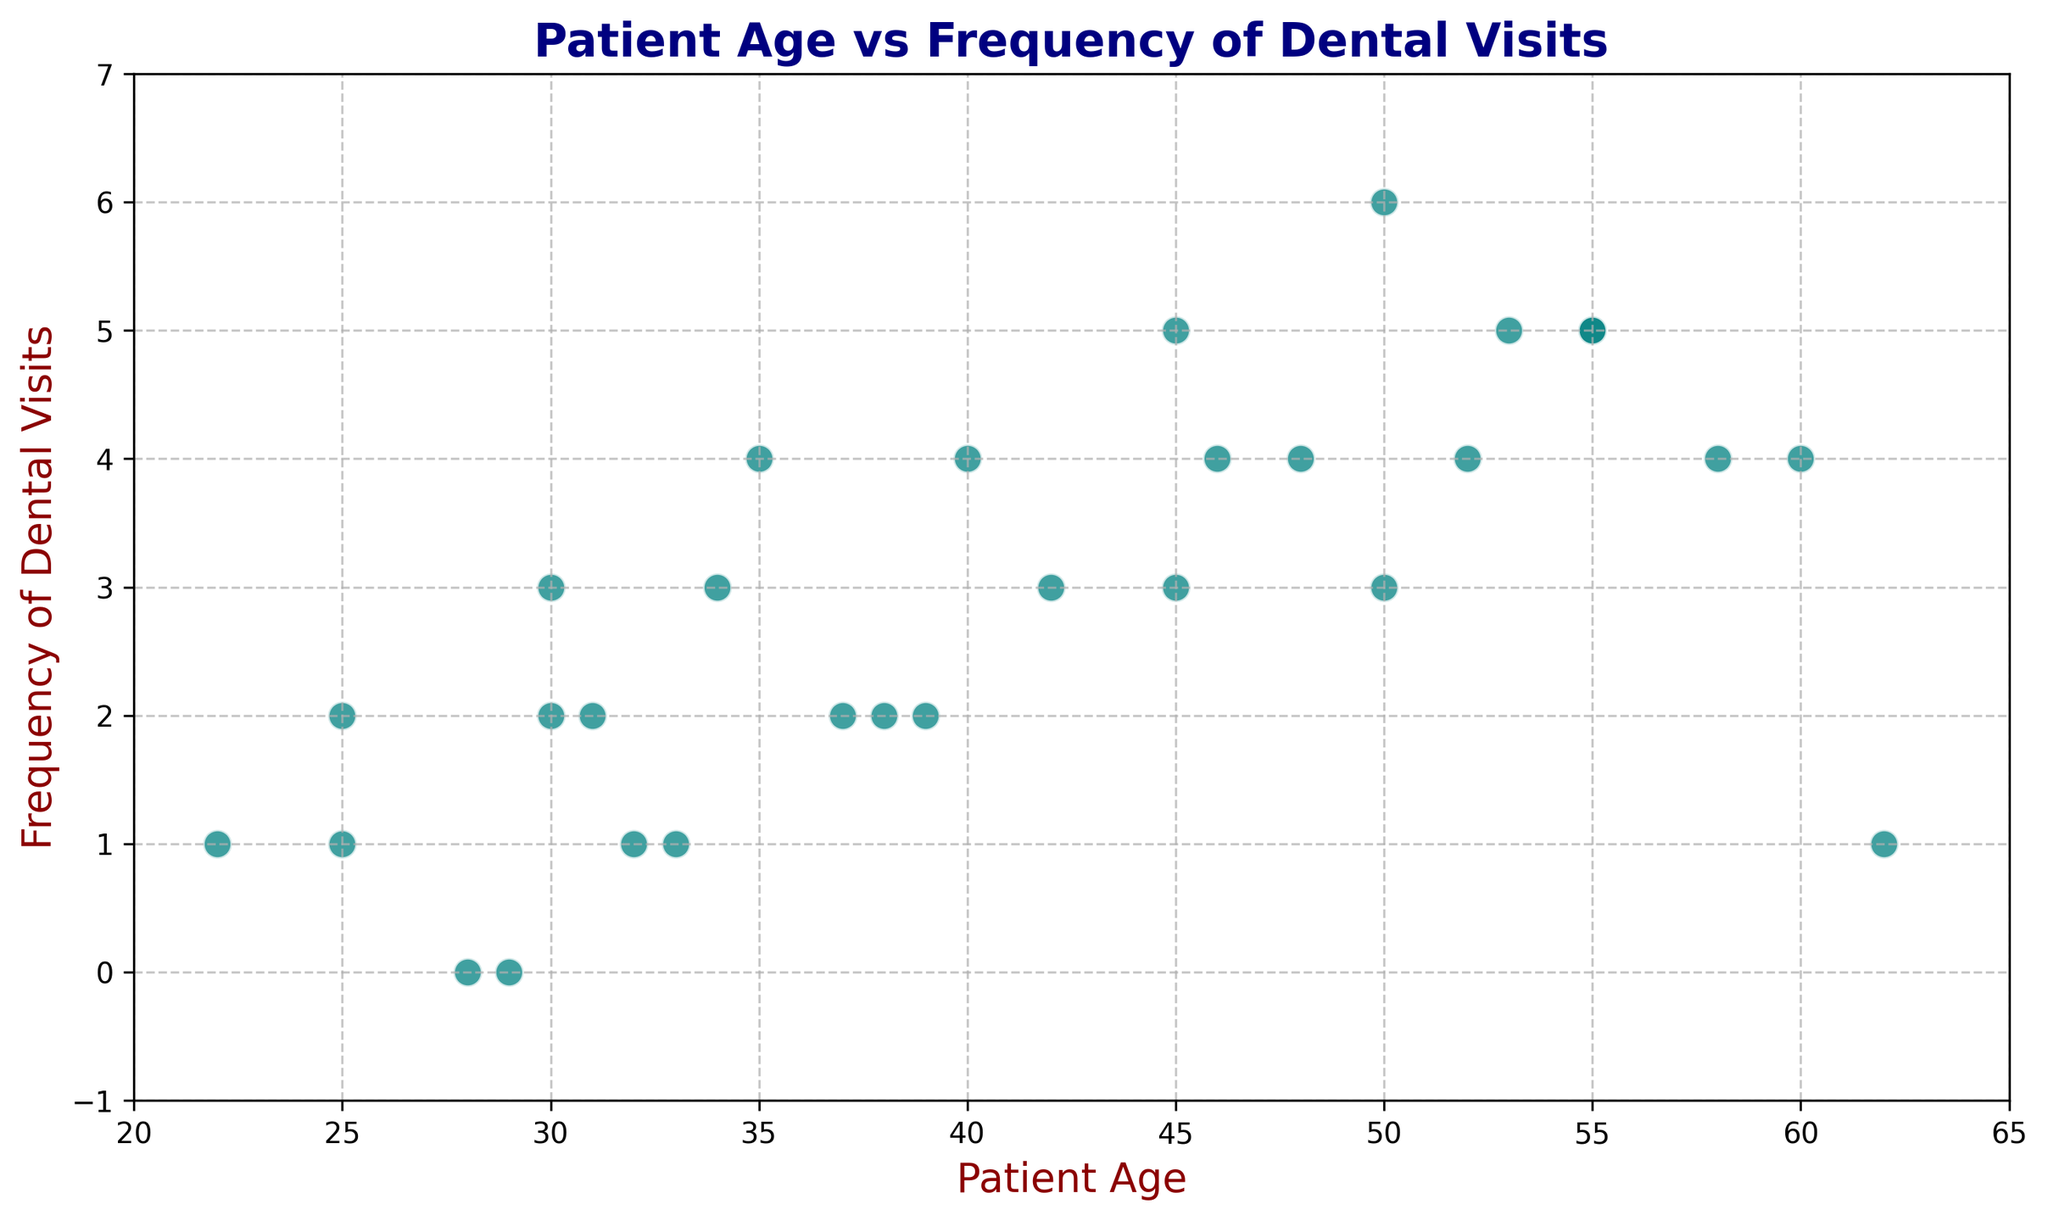What is the range of Patient Ages? The range of Patient Ages is determined by finding the minimum and maximum ages in the scatter plot. The minimum age is 22 and the maximum age is 62. Therefore, the range is 62 - 22.
Answer: 40 What is the most frequent number of dental visits for patients aged between 45 and 55? Observe the scatter plot for points within the age range of 45 to 55 and count the frequency of visits for these points. The most common frequency within this range is 5.
Answer: 5 What is the average frequency of dental visits for patients aged over 50? Identify the points where the Patient Age is greater than 50 and calculate the average frequency of visits for these points. The relevant frequencies are 6, 5, 4, 5, 4, 1. The average is (6 + 5 + 4 + 5 + 4 + 1) / 6 = 25 / 6.
Answer: Approximately 4.17 How many patients have a frequency of dental visits of more than 3 times per year, and what is their average age? Count the number of points with a frequency greater than 3, then sum their ages and divide by the count. The ages are 35, 40, 45, 50, 55, 55, 48, 53, 55. The count is 9, and the sum of the ages is 436. The average age is 436 / 9.
Answer: Approximately 48.44 Do patients in their 30s (age between 30 and 39) visit more frequently than those in their 50s (age between 50 and 59)? Sum the frequencies of visits for patients aged between 30 and 39 and compare it with those aged between 50 and 59. Ages 30-39: 3 + 2 + 4 + 3 + 2 = 14. Ages 50-59: 6 + 5 + 4 + 5 + 4 = 24.
Answer: No, patients in their 50s visit more frequently Is there a general trend in the frequency of dental visits as age increases? By visually inspecting the scatter plot, look for a pattern or trend as the age increases. There is an observable trend that the frequency increases with age until around 50 and then either remains constant or decreases slightly.
Answer: Yes What is the frequency of dental visits for the youngest patient? Identify the point with the smallest Patient Age, which is 22. The corresponding frequency of dental visits for this age is 1.
Answer: 1 Are there any patients who have never visited the dentist? If so, how many? Look for points on the scatter plot where the frequency of dental visits is 0. Patients aged 28 and 29 have a frequency of 0 visits.
Answer: Yes, 2 What is the total number of visits for patients aged 40 and above? Sum the frequencies of the visits for all points where Patient Age is 40 or above. The frequencies are 4, 5, 6, 5, 4, 1, 4, 5, 4. The total is 38.
Answer: 38 